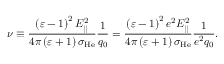<formula> <loc_0><loc_0><loc_500><loc_500>\nu \equiv \frac { \left ( \varepsilon - 1 \right ) ^ { 2 } E _ { | | } ^ { 2 } } { 4 \pi \left ( \varepsilon + 1 \right ) \sigma _ { H e } } \frac { 1 } { q _ { 0 } } = \frac { \left ( \varepsilon - 1 \right ) ^ { 2 } e ^ { 2 } E _ { | | } ^ { 2 } } { 4 \pi \left ( \varepsilon + 1 \right ) \sigma _ { H e } } \frac { 1 } { e ^ { 2 } q _ { 0 } } .</formula> 